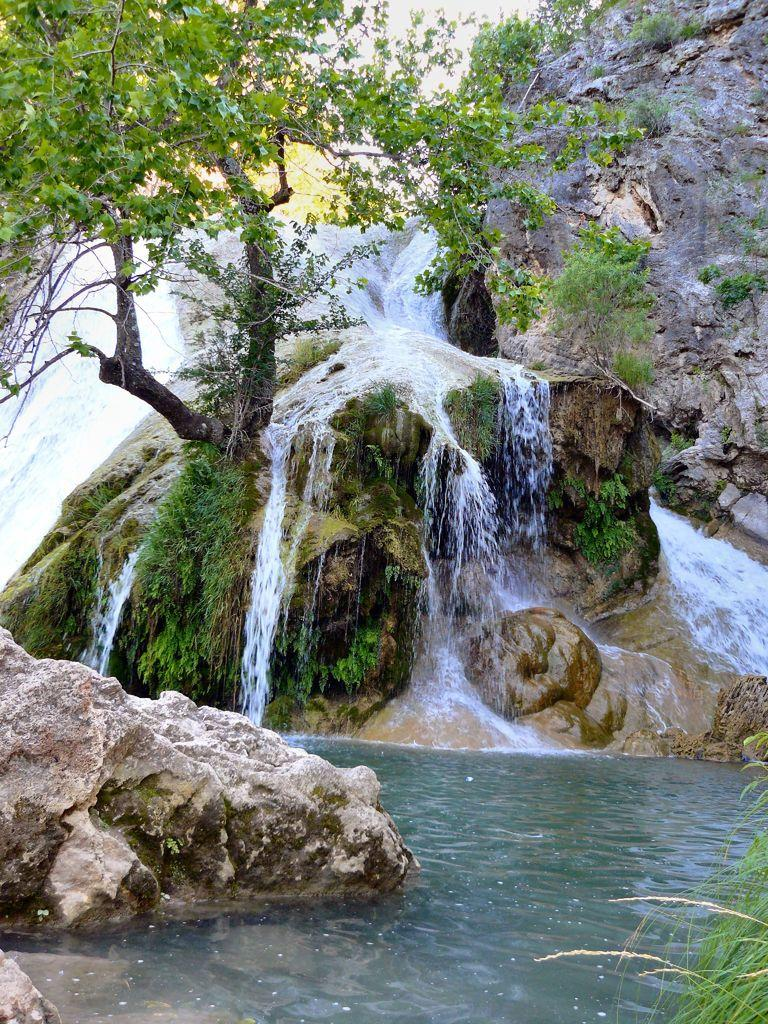What type of plant can be seen in the image? There is a tree in the image. What type of ground cover is present in the image? There is grass in the image. What other natural elements can be seen in the image? There are rocks in the image. What body of water is visible in the image? There is water visible in the image. What type of arithmetic problem is being solved on the tree in the image? There is no arithmetic problem present in the image; it features a tree, grass, rocks, and water. Can you tell me how many cacti are visible in the image? There are no cacti present in the image; it features a tree, grass, rocks, and water. 